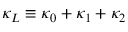Convert formula to latex. <formula><loc_0><loc_0><loc_500><loc_500>\kappa _ { L } \equiv \kappa _ { 0 } + \kappa _ { 1 } + \kappa _ { 2 }</formula> 